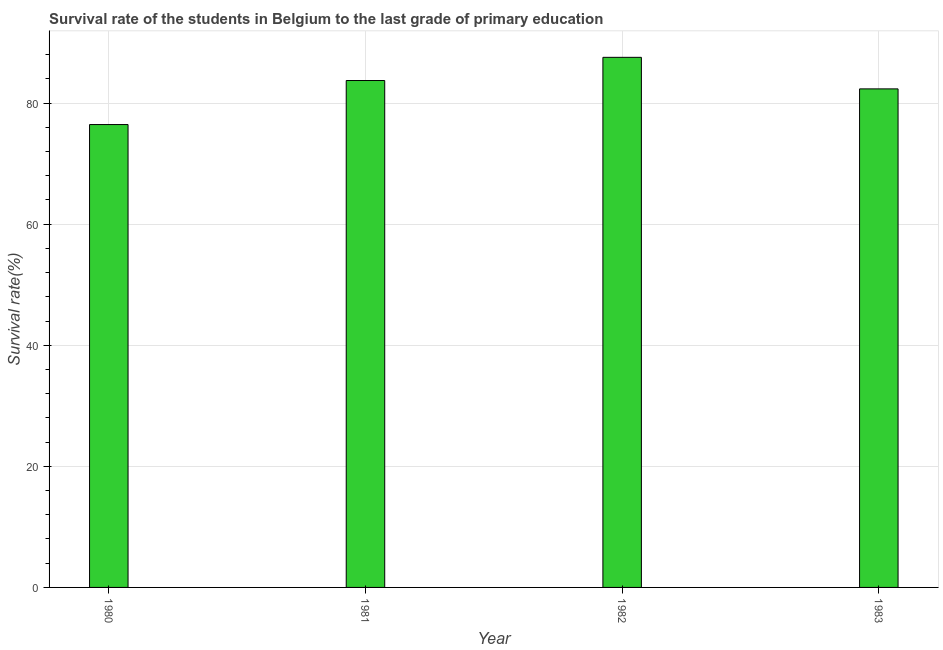Does the graph contain any zero values?
Give a very brief answer. No. What is the title of the graph?
Keep it short and to the point. Survival rate of the students in Belgium to the last grade of primary education. What is the label or title of the Y-axis?
Keep it short and to the point. Survival rate(%). What is the survival rate in primary education in 1982?
Keep it short and to the point. 87.55. Across all years, what is the maximum survival rate in primary education?
Ensure brevity in your answer.  87.55. Across all years, what is the minimum survival rate in primary education?
Offer a terse response. 76.45. What is the sum of the survival rate in primary education?
Ensure brevity in your answer.  330.07. What is the difference between the survival rate in primary education in 1982 and 1983?
Offer a terse response. 5.21. What is the average survival rate in primary education per year?
Your response must be concise. 82.52. What is the median survival rate in primary education?
Keep it short and to the point. 83.03. Do a majority of the years between 1982 and 1980 (inclusive) have survival rate in primary education greater than 24 %?
Your response must be concise. Yes. Is the difference between the survival rate in primary education in 1980 and 1983 greater than the difference between any two years?
Your response must be concise. No. What is the difference between the highest and the second highest survival rate in primary education?
Make the answer very short. 3.83. What is the difference between the highest and the lowest survival rate in primary education?
Offer a terse response. 11.1. In how many years, is the survival rate in primary education greater than the average survival rate in primary education taken over all years?
Offer a very short reply. 2. What is the difference between two consecutive major ticks on the Y-axis?
Offer a terse response. 20. What is the Survival rate(%) in 1980?
Give a very brief answer. 76.45. What is the Survival rate(%) in 1981?
Give a very brief answer. 83.72. What is the Survival rate(%) in 1982?
Your answer should be compact. 87.55. What is the Survival rate(%) of 1983?
Ensure brevity in your answer.  82.34. What is the difference between the Survival rate(%) in 1980 and 1981?
Provide a short and direct response. -7.27. What is the difference between the Survival rate(%) in 1980 and 1982?
Your response must be concise. -11.1. What is the difference between the Survival rate(%) in 1980 and 1983?
Ensure brevity in your answer.  -5.89. What is the difference between the Survival rate(%) in 1981 and 1982?
Your answer should be compact. -3.83. What is the difference between the Survival rate(%) in 1981 and 1983?
Give a very brief answer. 1.38. What is the difference between the Survival rate(%) in 1982 and 1983?
Offer a terse response. 5.21. What is the ratio of the Survival rate(%) in 1980 to that in 1982?
Provide a succinct answer. 0.87. What is the ratio of the Survival rate(%) in 1980 to that in 1983?
Make the answer very short. 0.93. What is the ratio of the Survival rate(%) in 1981 to that in 1982?
Your answer should be very brief. 0.96. What is the ratio of the Survival rate(%) in 1981 to that in 1983?
Provide a succinct answer. 1.02. What is the ratio of the Survival rate(%) in 1982 to that in 1983?
Your answer should be very brief. 1.06. 